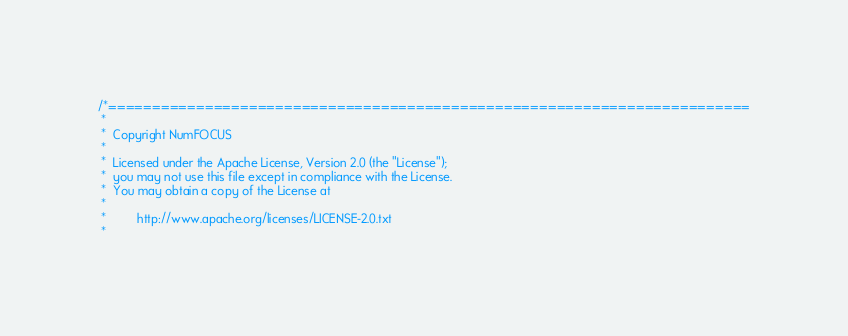<code> <loc_0><loc_0><loc_500><loc_500><_C++_>/*=========================================================================
 *
 *  Copyright NumFOCUS
 *
 *  Licensed under the Apache License, Version 2.0 (the "License");
 *  you may not use this file except in compliance with the License.
 *  You may obtain a copy of the License at
 *
 *         http://www.apache.org/licenses/LICENSE-2.0.txt
 *</code> 